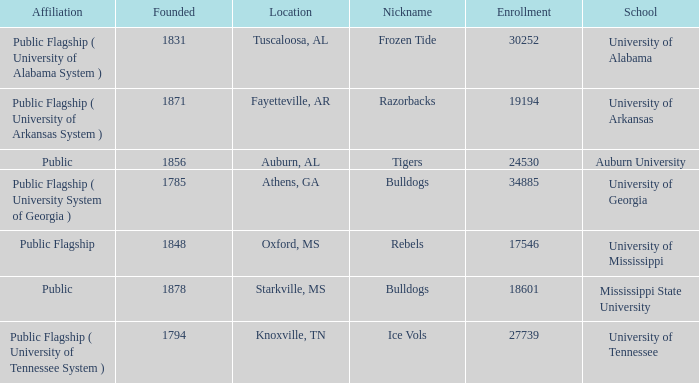What is the nickname of the University of Alabama? Frozen Tide. 